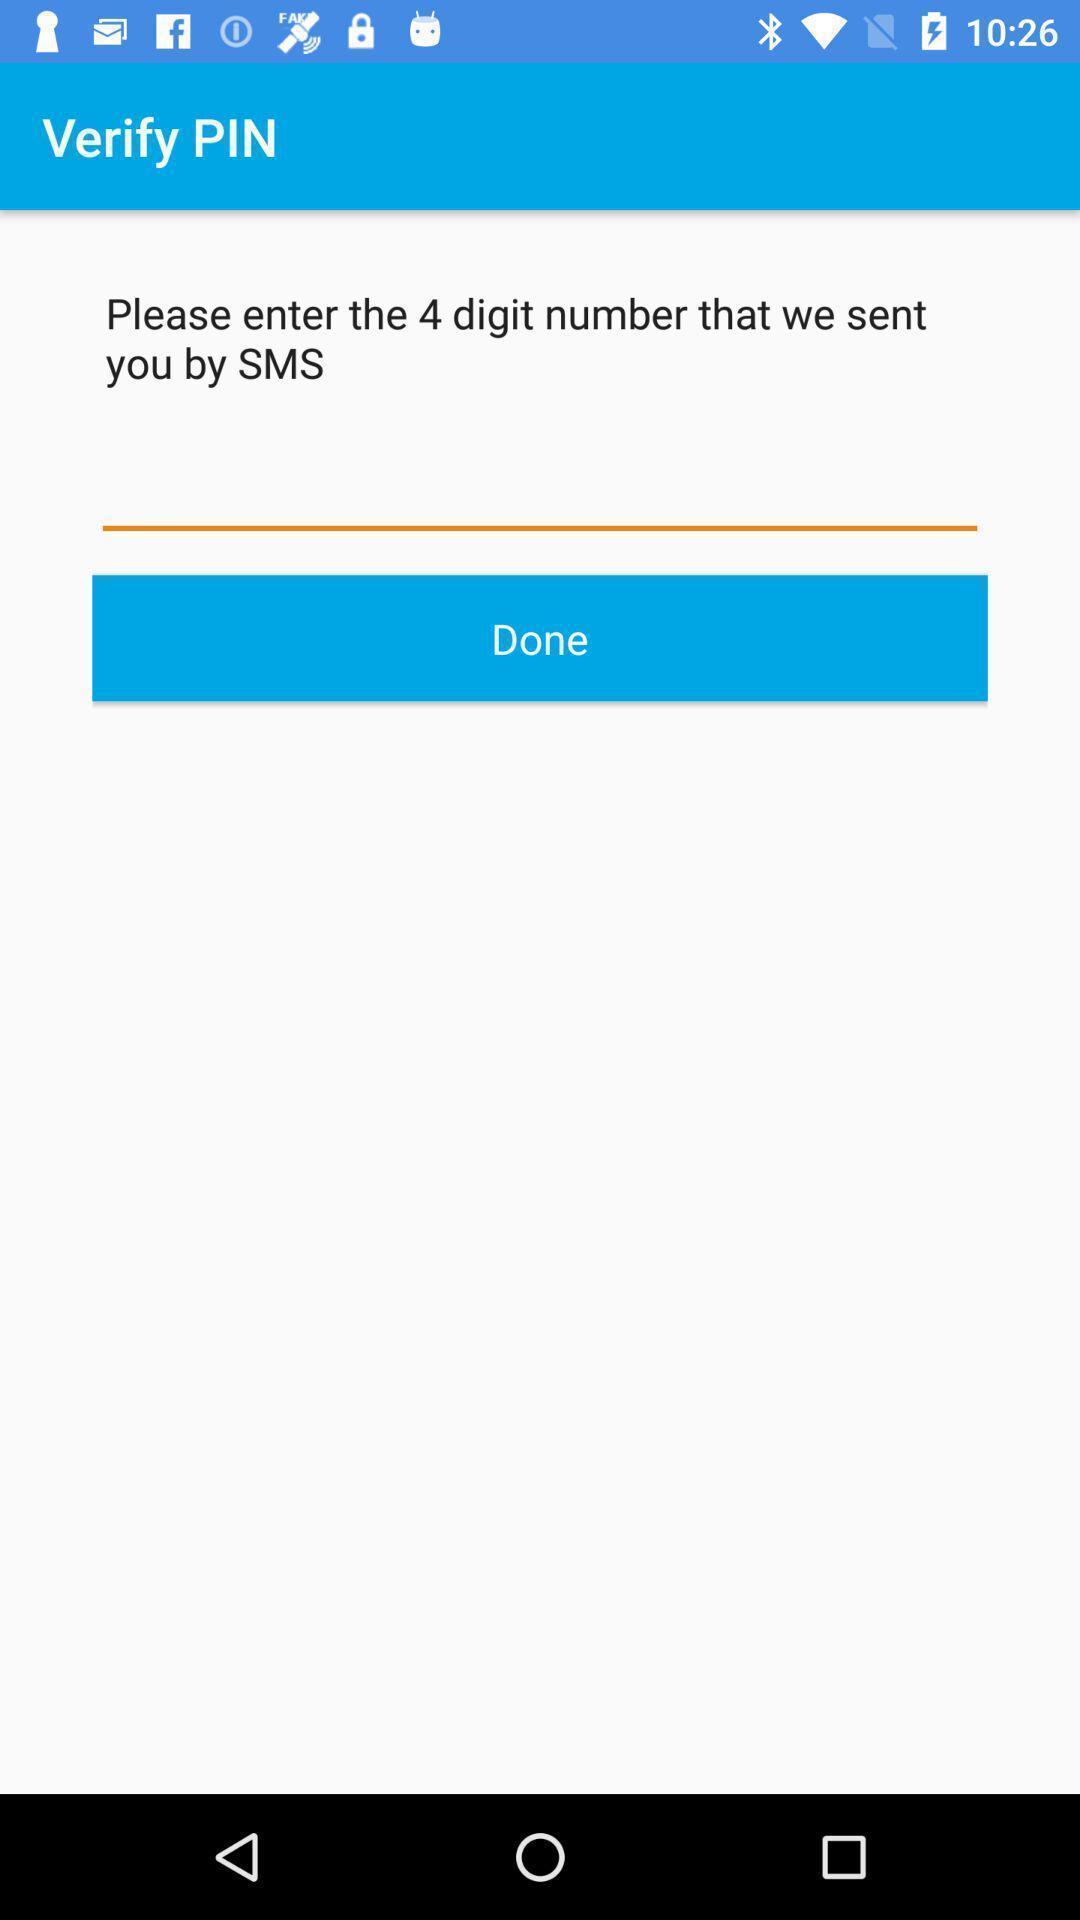Describe the key features of this screenshot. Verification page. 